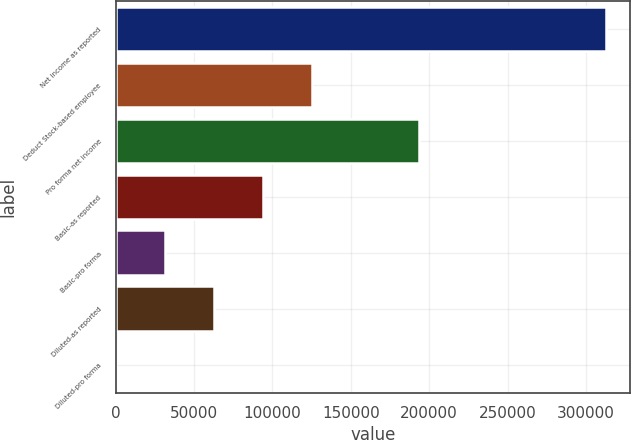Convert chart to OTSL. <chart><loc_0><loc_0><loc_500><loc_500><bar_chart><fcel>Net income as reported<fcel>Deduct Stock-based employee<fcel>Pro forma net income<fcel>Basic-as reported<fcel>Basic-pro forma<fcel>Diluted-as reported<fcel>Diluted-pro forma<nl><fcel>312723<fcel>125090<fcel>193486<fcel>93817.3<fcel>31272.8<fcel>62545<fcel>0.54<nl></chart> 